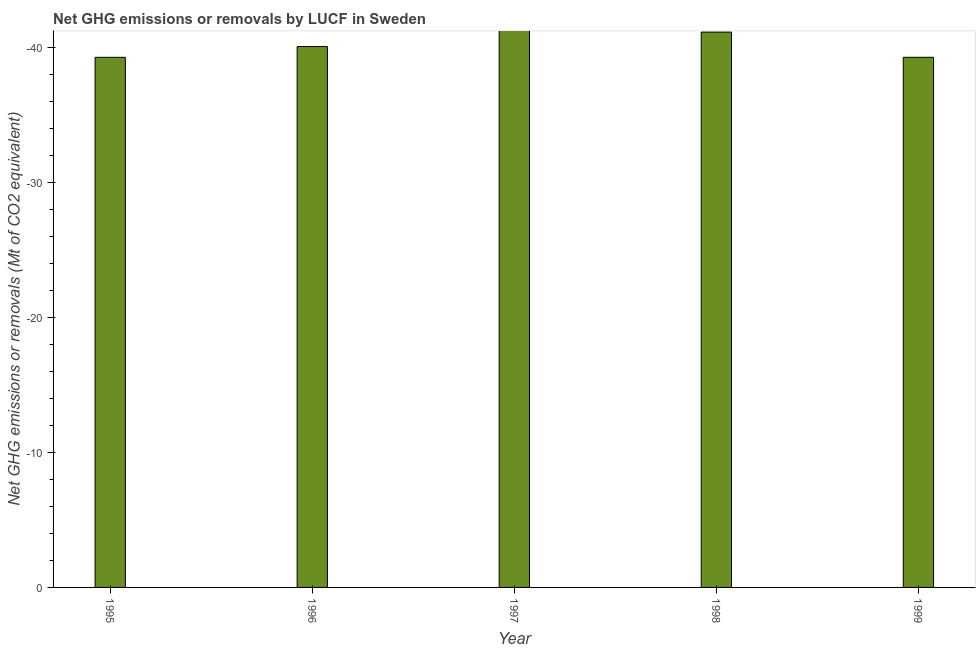Does the graph contain any zero values?
Provide a short and direct response. Yes. Does the graph contain grids?
Keep it short and to the point. No. What is the title of the graph?
Make the answer very short. Net GHG emissions or removals by LUCF in Sweden. What is the label or title of the X-axis?
Offer a very short reply. Year. What is the label or title of the Y-axis?
Your answer should be compact. Net GHG emissions or removals (Mt of CO2 equivalent). What is the ghg net emissions or removals in 1999?
Your response must be concise. 0. What is the average ghg net emissions or removals per year?
Provide a succinct answer. 0. How many bars are there?
Make the answer very short. 0. Are all the bars in the graph horizontal?
Your answer should be compact. No. What is the Net GHG emissions or removals (Mt of CO2 equivalent) in 1996?
Provide a succinct answer. 0. What is the Net GHG emissions or removals (Mt of CO2 equivalent) in 1997?
Make the answer very short. 0. 